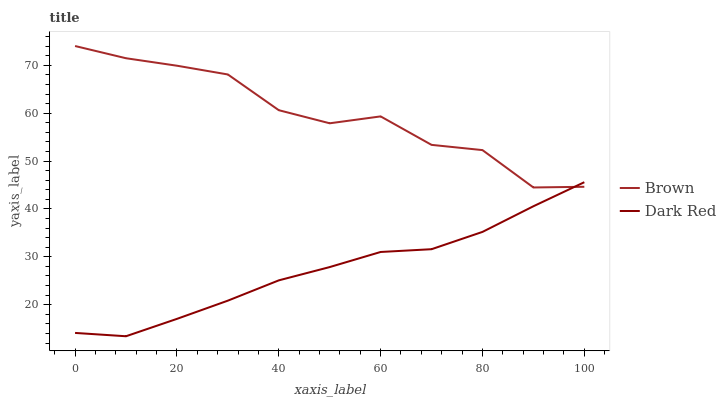Does Dark Red have the minimum area under the curve?
Answer yes or no. Yes. Does Brown have the maximum area under the curve?
Answer yes or no. Yes. Does Dark Red have the maximum area under the curve?
Answer yes or no. No. Is Dark Red the smoothest?
Answer yes or no. Yes. Is Brown the roughest?
Answer yes or no. Yes. Is Dark Red the roughest?
Answer yes or no. No. Does Dark Red have the lowest value?
Answer yes or no. Yes. Does Brown have the highest value?
Answer yes or no. Yes. Does Dark Red have the highest value?
Answer yes or no. No. Does Dark Red intersect Brown?
Answer yes or no. Yes. Is Dark Red less than Brown?
Answer yes or no. No. Is Dark Red greater than Brown?
Answer yes or no. No. 